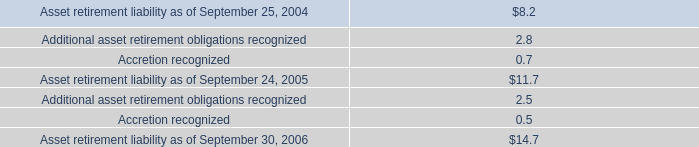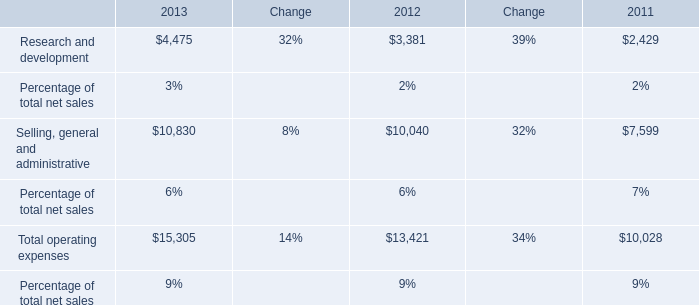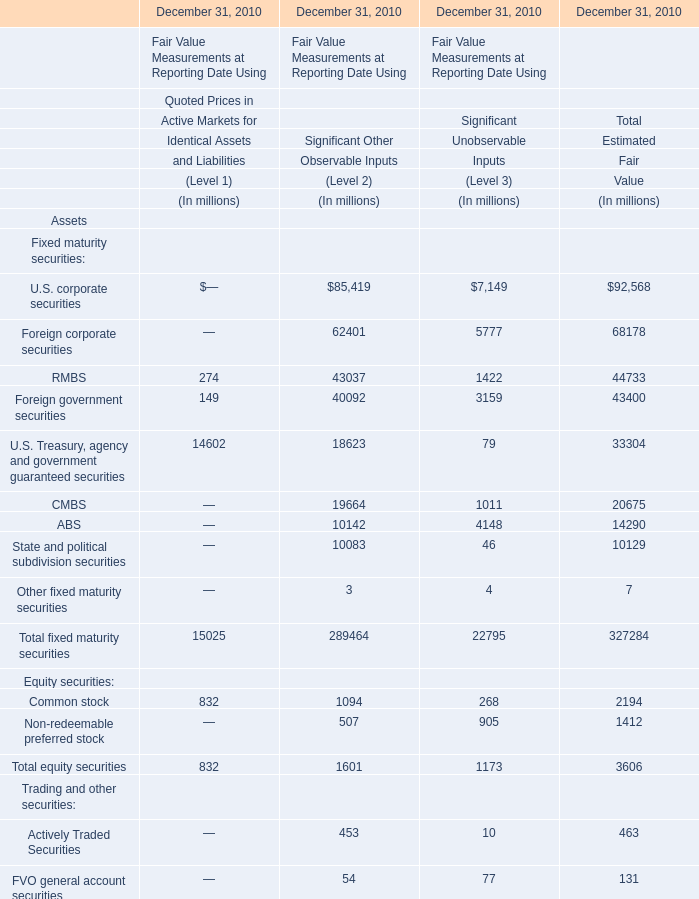by how much did asset retirement liability increase from 2005 to 2006? 
Computations: ((14.7 - 11.7) / 11.7)
Answer: 0.25641. 